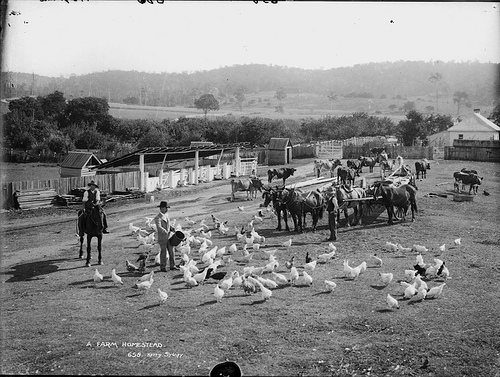Describe the setting where these birds are found. The birds are situated on a farmstead, evident by the open space, surrounding fences, and agricultural equipment. This type of setting typically provides the birds with the freedom to roam and forage. 